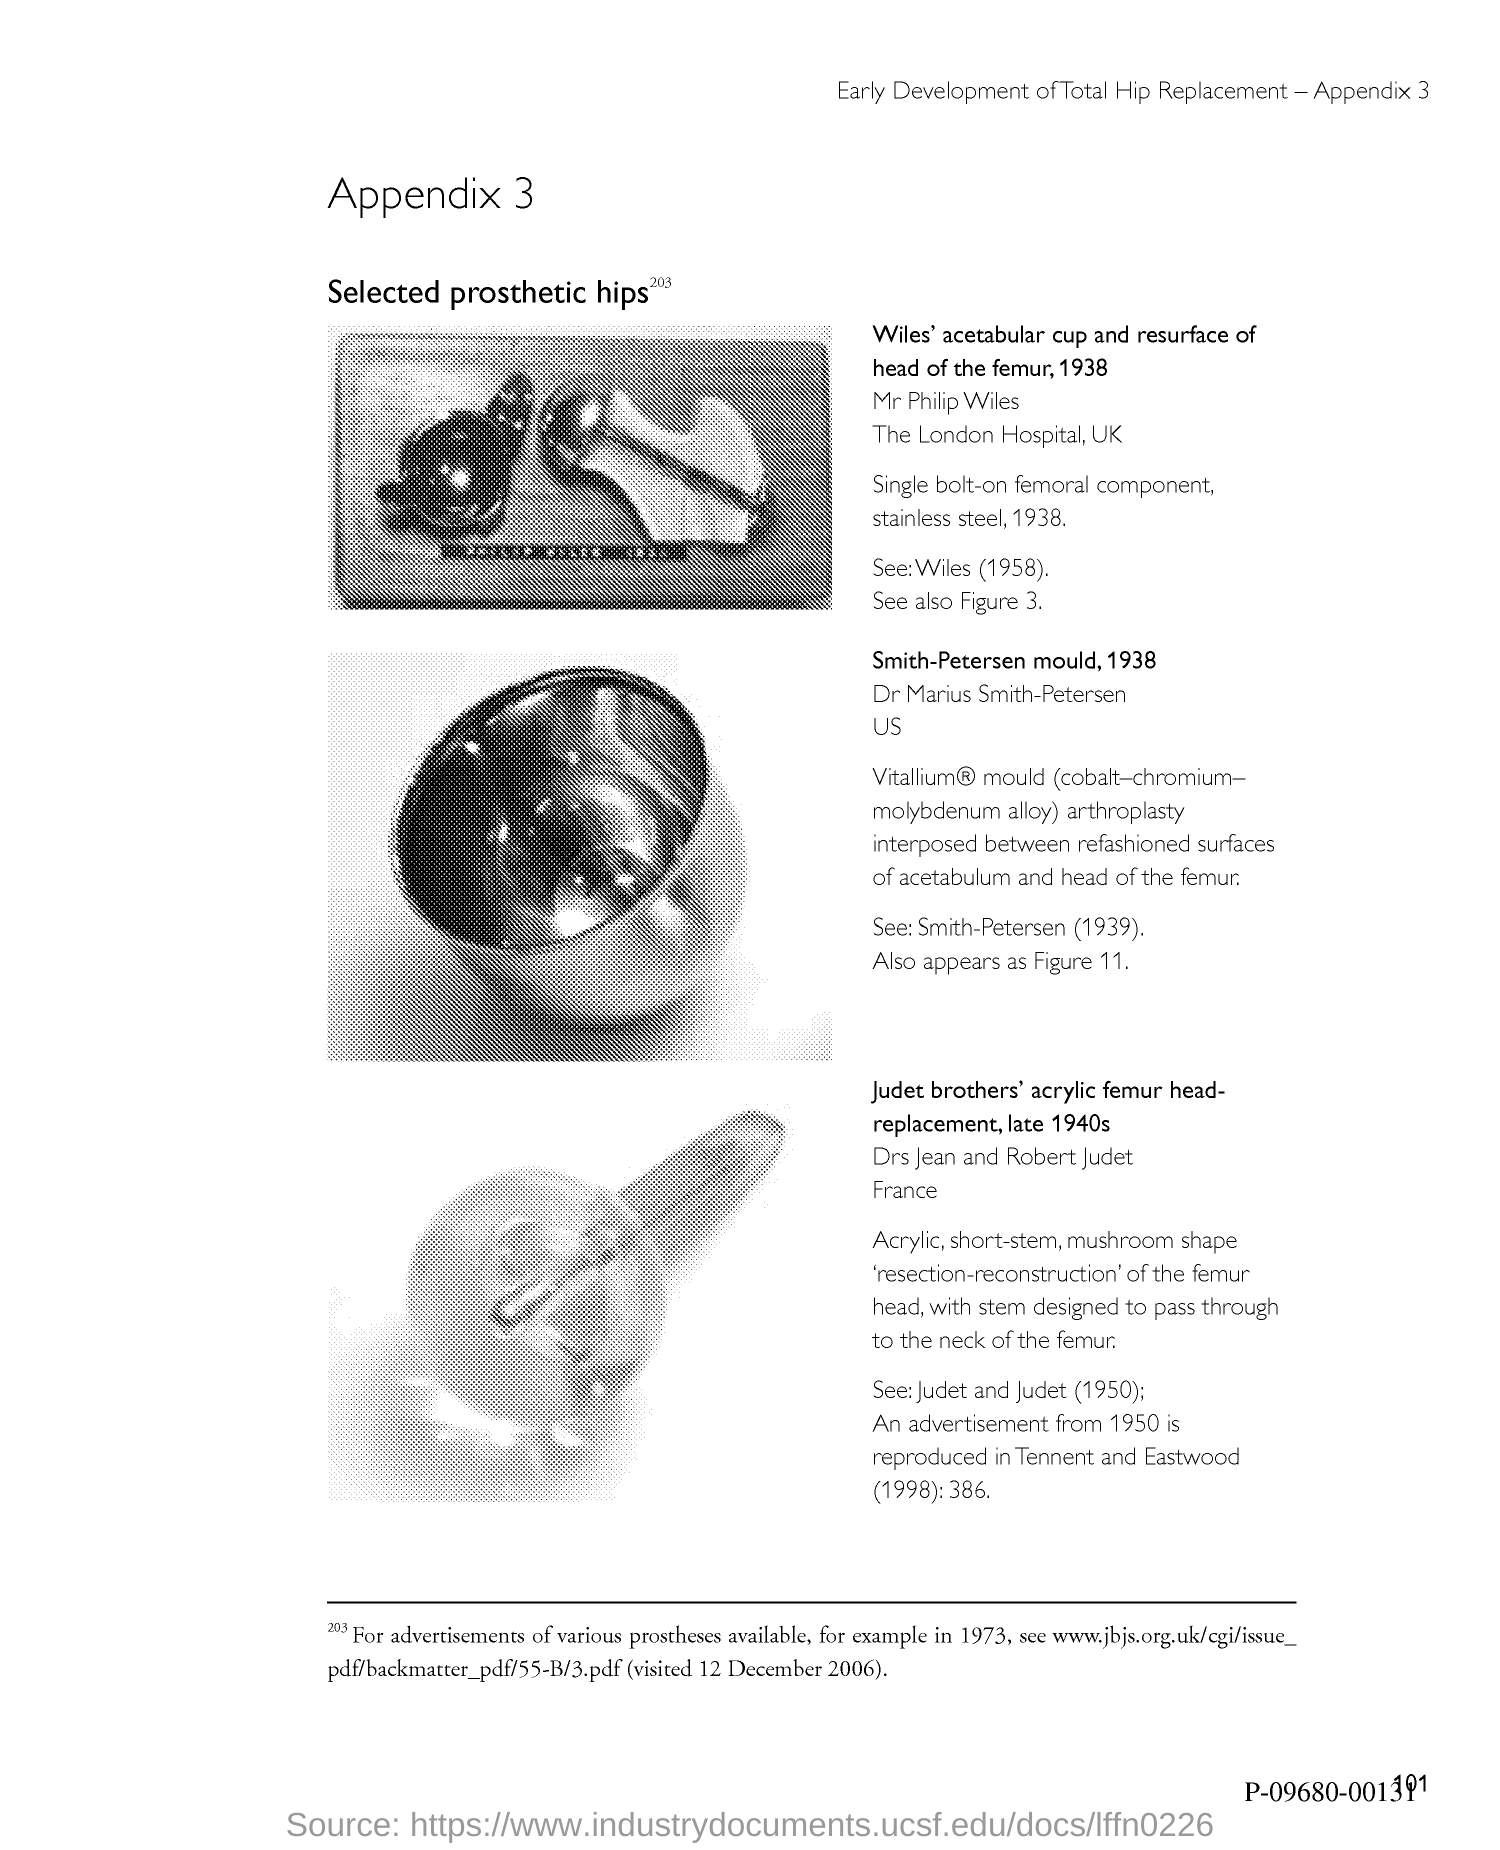What is the title of the document?
Offer a terse response. Appendix 3. What is the Page Number?
Your answer should be compact. 101. 